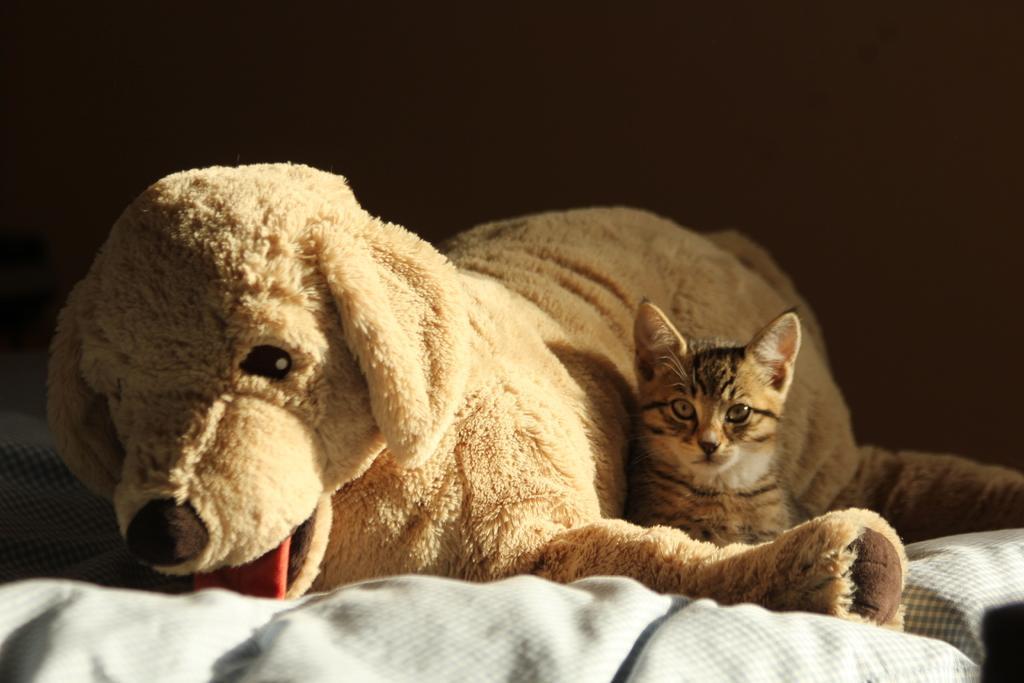Could you give a brief overview of what you see in this image? In the foreground I can see a toy dog and a cat is sitting on the bed. The background is very dark in color. This image is taken in a room. 